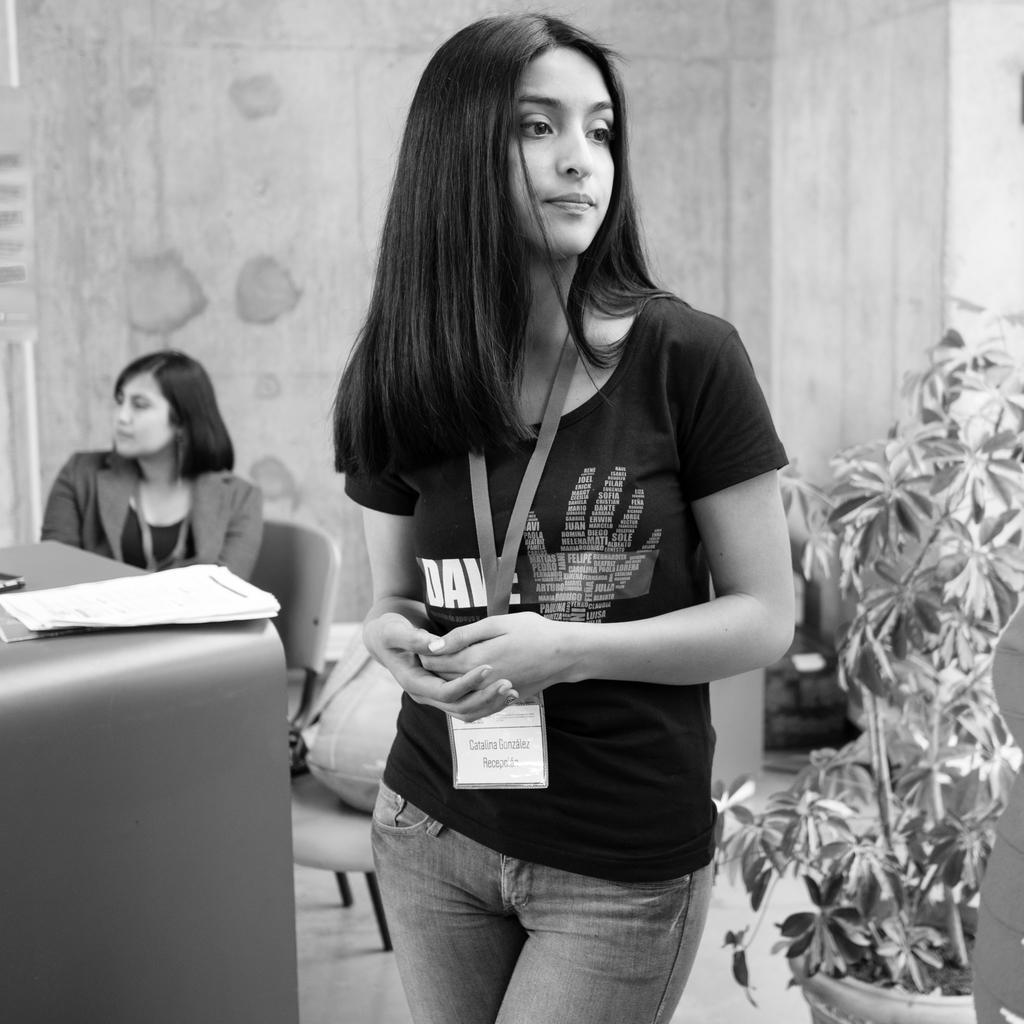Could you give a brief overview of what you see in this image? This is a black and white image. In the center of the image we can see a lady is standing and wearing shirt, jeans, id card. On the right side of the image we can see a pot with plant. On the left side of the image we can see a lady is sitting on a chair and also we can see a chair, table. On the table we can see the papers, objects. On the chair we can see an object. In the background of the image we can see the wall and some other objects. At the bottom of the image we can see the floor. 